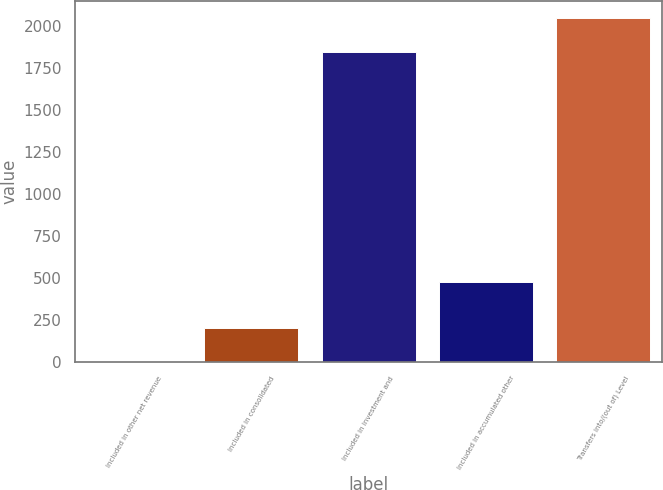Convert chart to OTSL. <chart><loc_0><loc_0><loc_500><loc_500><bar_chart><fcel>Included in other net revenue<fcel>Included in consolidated<fcel>Included in investment and<fcel>Included in accumulated other<fcel>Transfers into/(out of) Level<nl><fcel>1.83<fcel>202.05<fcel>1847<fcel>476<fcel>2047.22<nl></chart> 